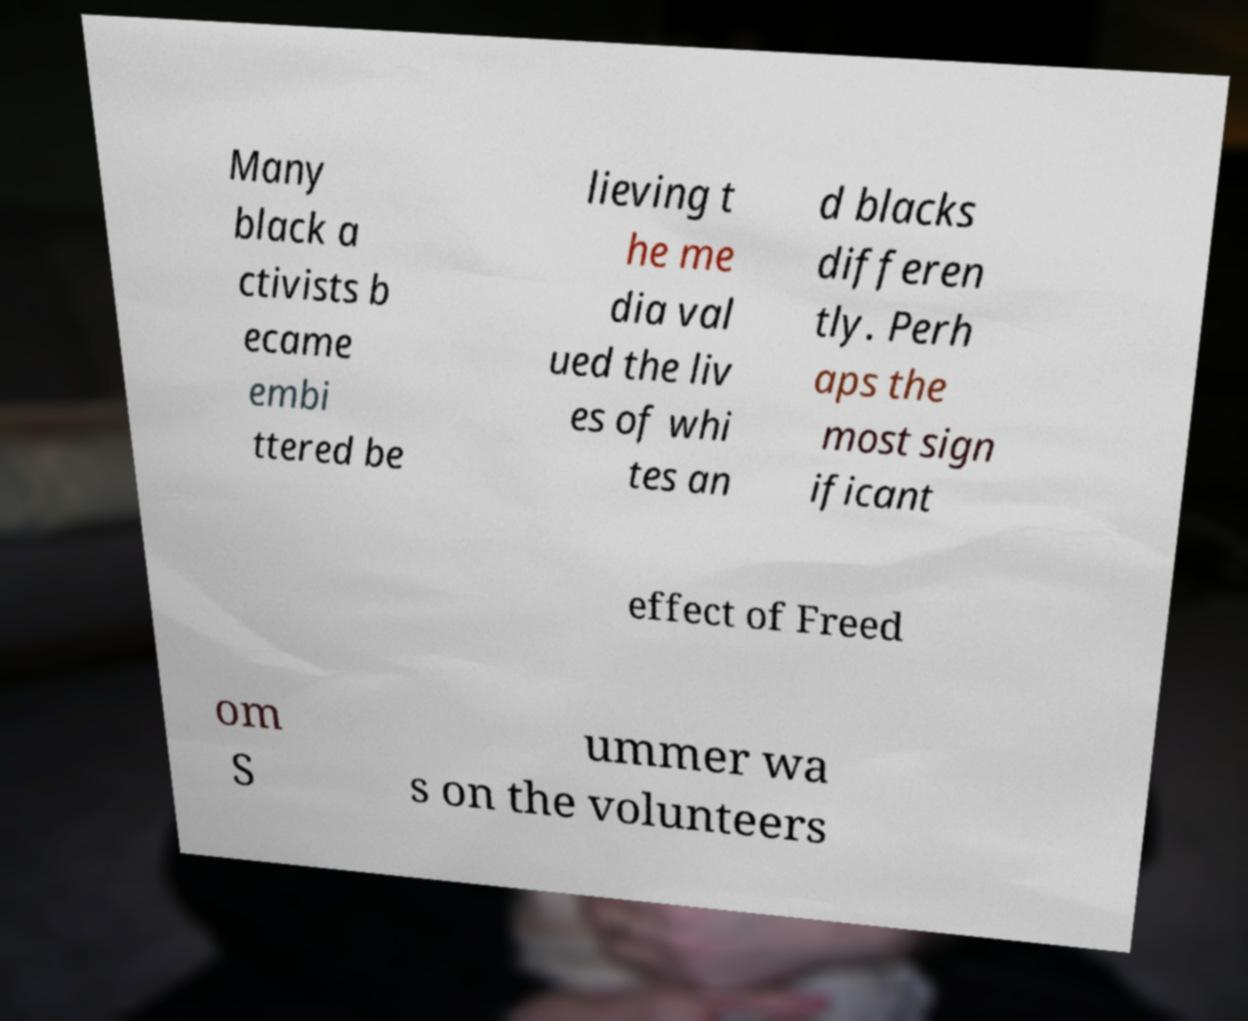Please identify and transcribe the text found in this image. Many black a ctivists b ecame embi ttered be lieving t he me dia val ued the liv es of whi tes an d blacks differen tly. Perh aps the most sign ificant effect of Freed om S ummer wa s on the volunteers 